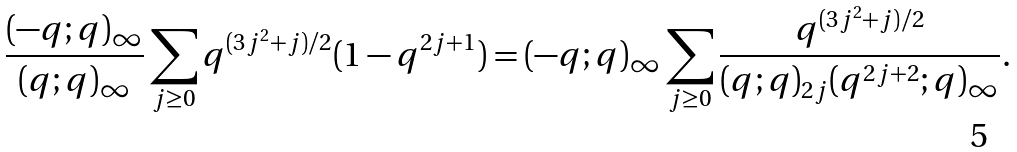<formula> <loc_0><loc_0><loc_500><loc_500>\frac { ( - q ; q ) _ { \infty } } { ( q ; q ) _ { \infty } } \sum _ { j \geq 0 } q ^ { { ( 3 j ^ { 2 } + j ) } / { 2 } } ( 1 - q ^ { 2 j + 1 } ) = { ( - q ; q ) _ { \infty } } \sum _ { j \geq 0 } \frac { q ^ { { ( 3 j ^ { 2 } + j ) } / { 2 } } } { ( q ; q ) _ { 2 j } ( q ^ { 2 j + 2 } ; q ) _ { \infty } } .</formula> 